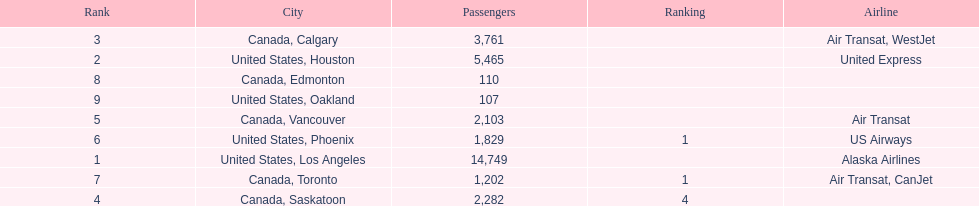Was los angeles or houston the busiest international route at manzanillo international airport in 2013? Los Angeles. 